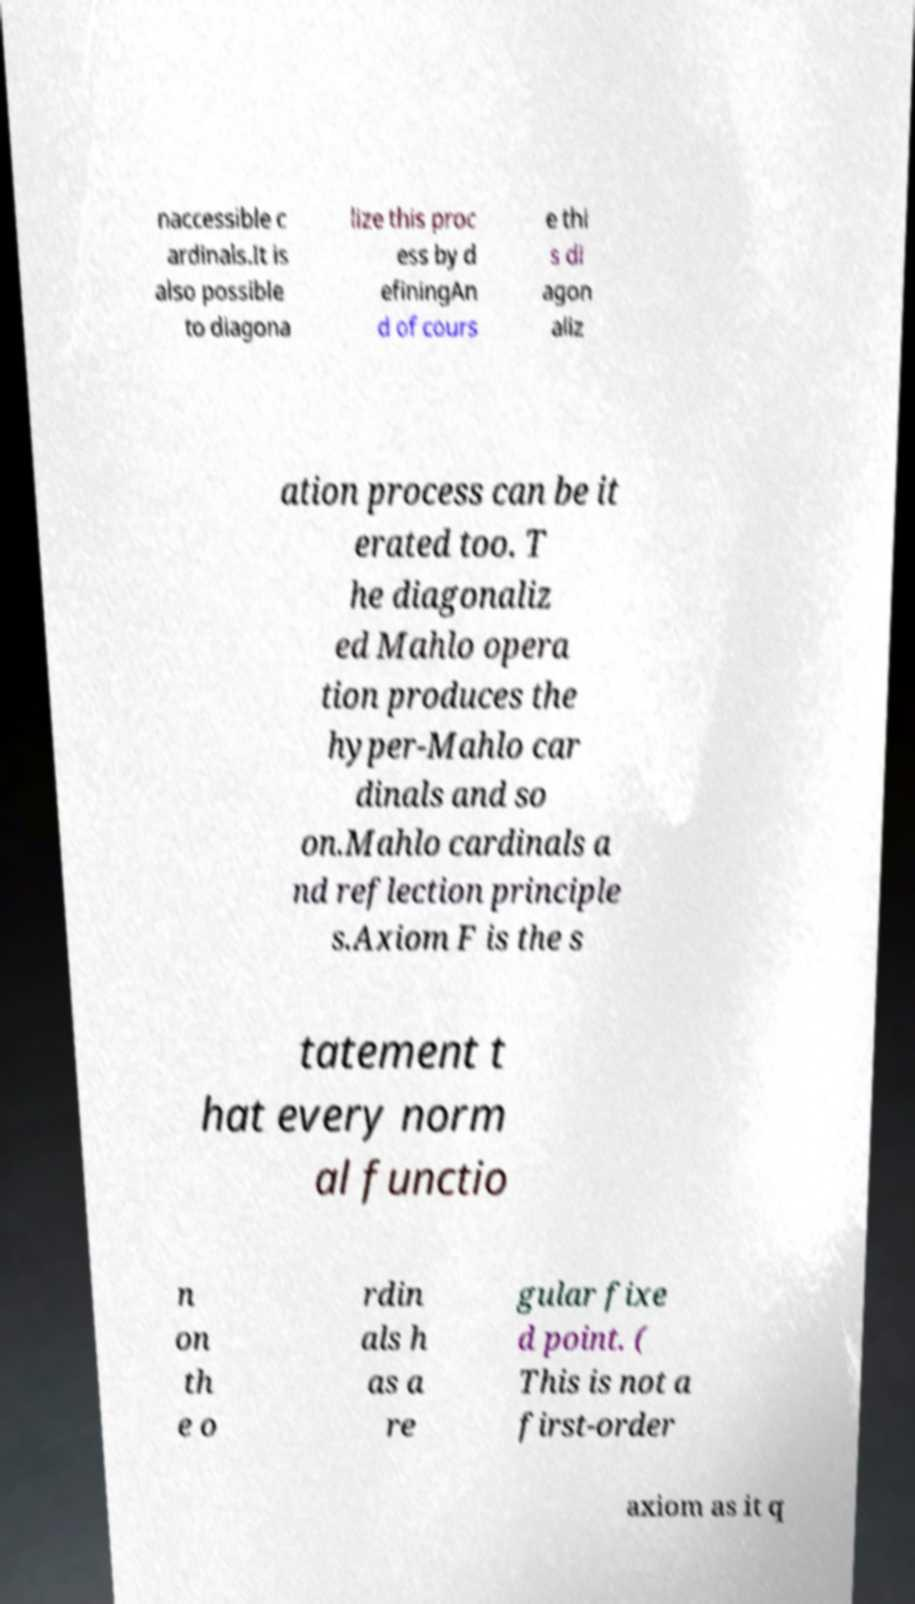Could you extract and type out the text from this image? naccessible c ardinals.It is also possible to diagona lize this proc ess by d efiningAn d of cours e thi s di agon aliz ation process can be it erated too. T he diagonaliz ed Mahlo opera tion produces the hyper-Mahlo car dinals and so on.Mahlo cardinals a nd reflection principle s.Axiom F is the s tatement t hat every norm al functio n on th e o rdin als h as a re gular fixe d point. ( This is not a first-order axiom as it q 